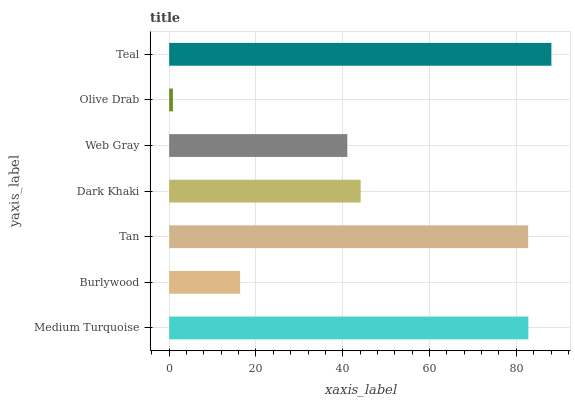Is Olive Drab the minimum?
Answer yes or no. Yes. Is Teal the maximum?
Answer yes or no. Yes. Is Burlywood the minimum?
Answer yes or no. No. Is Burlywood the maximum?
Answer yes or no. No. Is Medium Turquoise greater than Burlywood?
Answer yes or no. Yes. Is Burlywood less than Medium Turquoise?
Answer yes or no. Yes. Is Burlywood greater than Medium Turquoise?
Answer yes or no. No. Is Medium Turquoise less than Burlywood?
Answer yes or no. No. Is Dark Khaki the high median?
Answer yes or no. Yes. Is Dark Khaki the low median?
Answer yes or no. Yes. Is Teal the high median?
Answer yes or no. No. Is Olive Drab the low median?
Answer yes or no. No. 